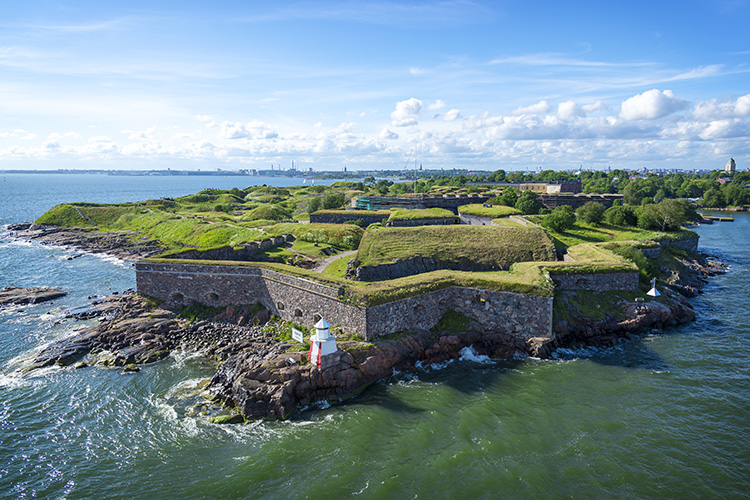What can you tell me about the ecosystem and natural environment around the fortress? The islands on which the Suomenlinna Fortress is built provide a unique ecological niche. The surrounding waters are brimming with marine life, and the grassy areas atop the fortress walls are home to various bird species and small mammals. The vegetation on the islands consists mostly of hardy grasses and shrubs, adapted to the harsh Baltic climate. Environmental conservation efforts are crucial in maintaining the delicate balance of this ecosystem, protecting it from the impacts of tourism and local activities. 